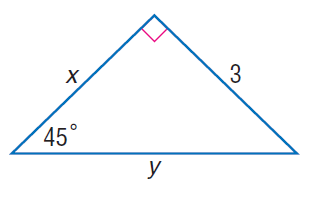Question: Find x.
Choices:
A. 3
B. 3 \sqrt { 2 }
C. 6
D. 6 \sqrt { 2 }
Answer with the letter. Answer: A 